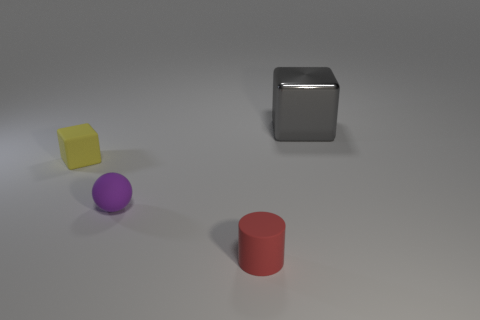Add 1 yellow shiny cubes. How many objects exist? 5 Subtract all spheres. How many objects are left? 3 Subtract all large green matte spheres. Subtract all purple matte spheres. How many objects are left? 3 Add 1 purple things. How many purple things are left? 2 Add 1 purple shiny spheres. How many purple shiny spheres exist? 1 Subtract 0 purple cylinders. How many objects are left? 4 